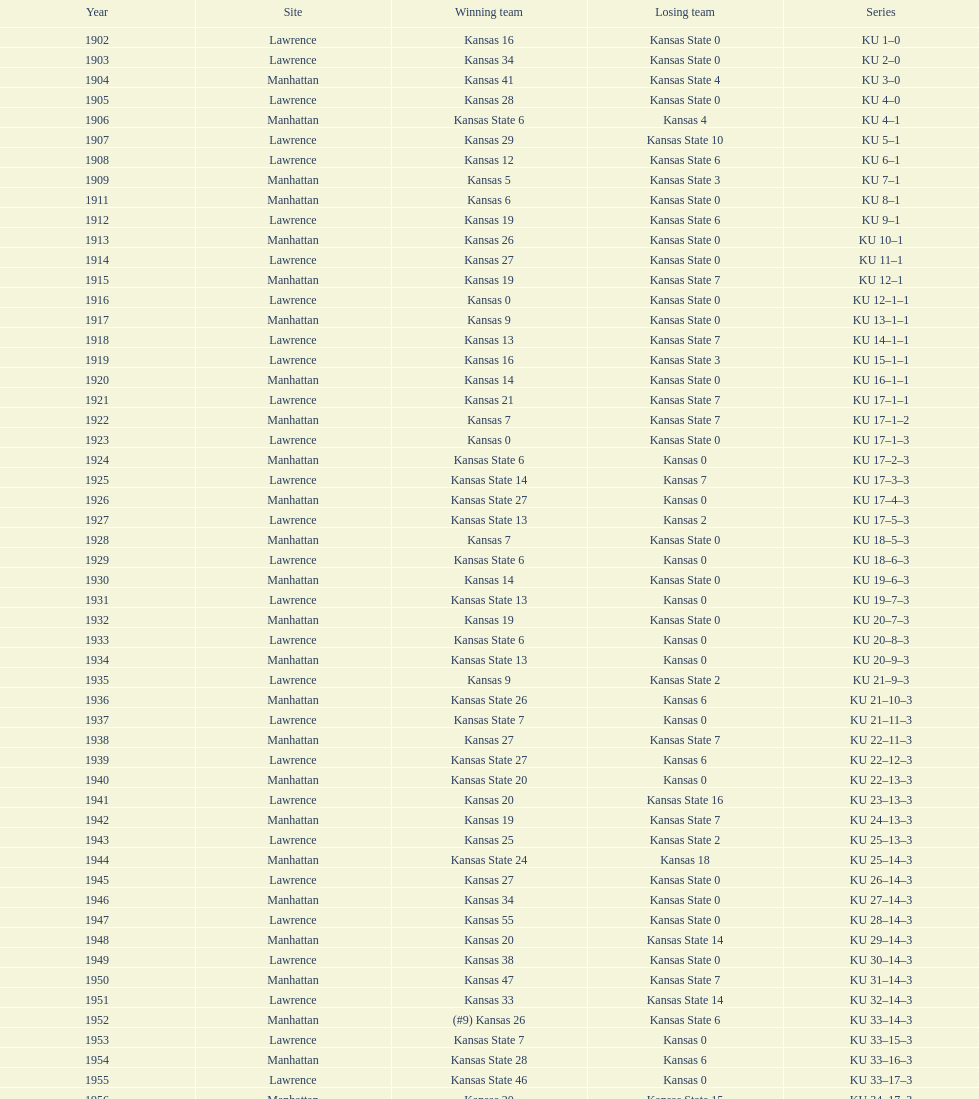What was the number of wins kansas state had in manhattan? 8. 